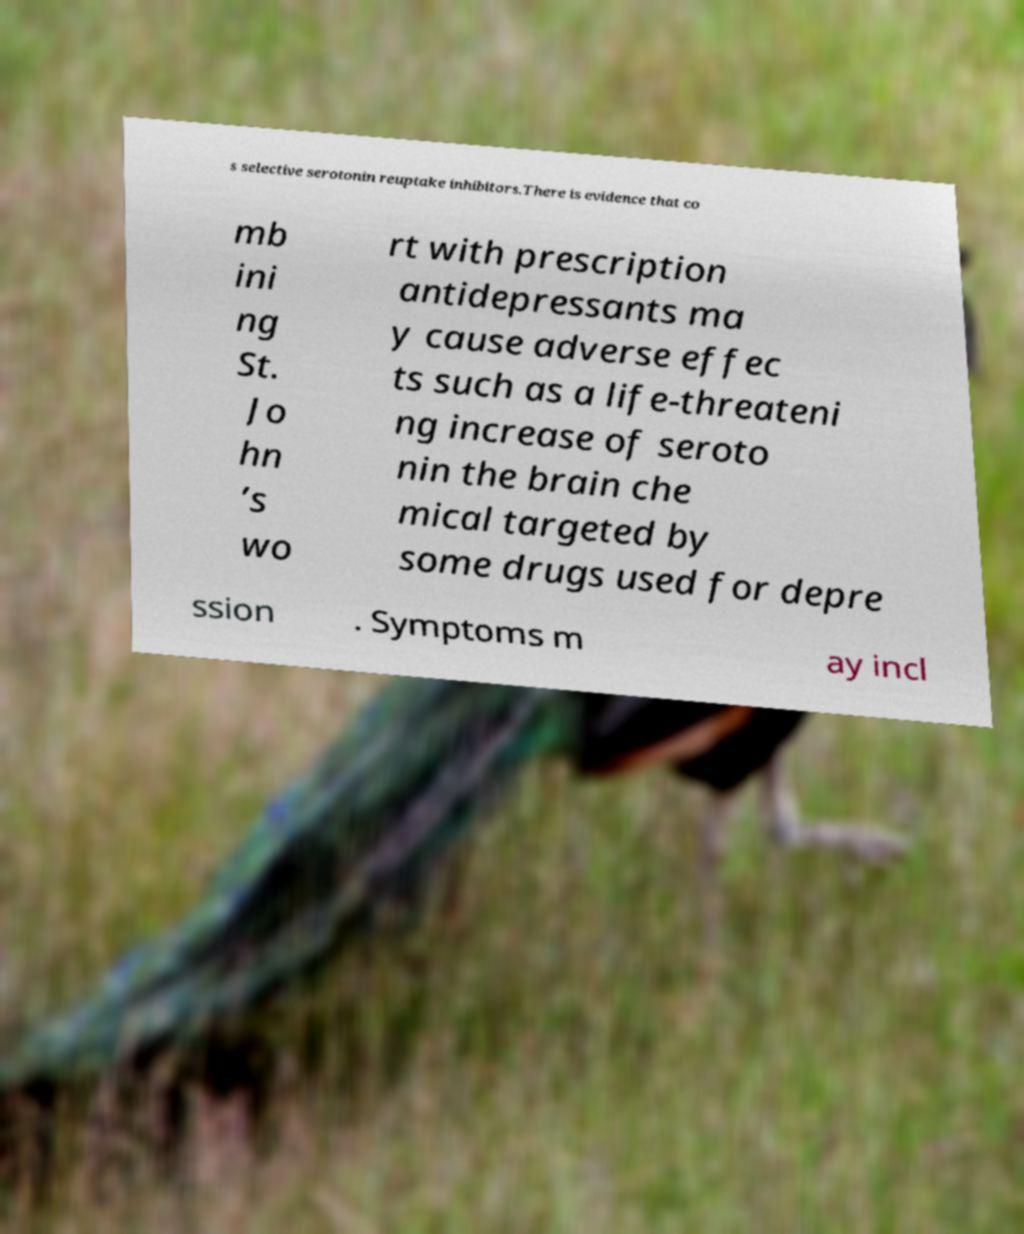Please identify and transcribe the text found in this image. s selective serotonin reuptake inhibitors.There is evidence that co mb ini ng St. Jo hn ’s wo rt with prescription antidepressants ma y cause adverse effec ts such as a life-threateni ng increase of seroto nin the brain che mical targeted by some drugs used for depre ssion . Symptoms m ay incl 